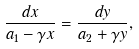<formula> <loc_0><loc_0><loc_500><loc_500>\frac { d x } { a _ { 1 } - \gamma x } = \frac { d y } { a _ { 2 } + \gamma y } ,</formula> 